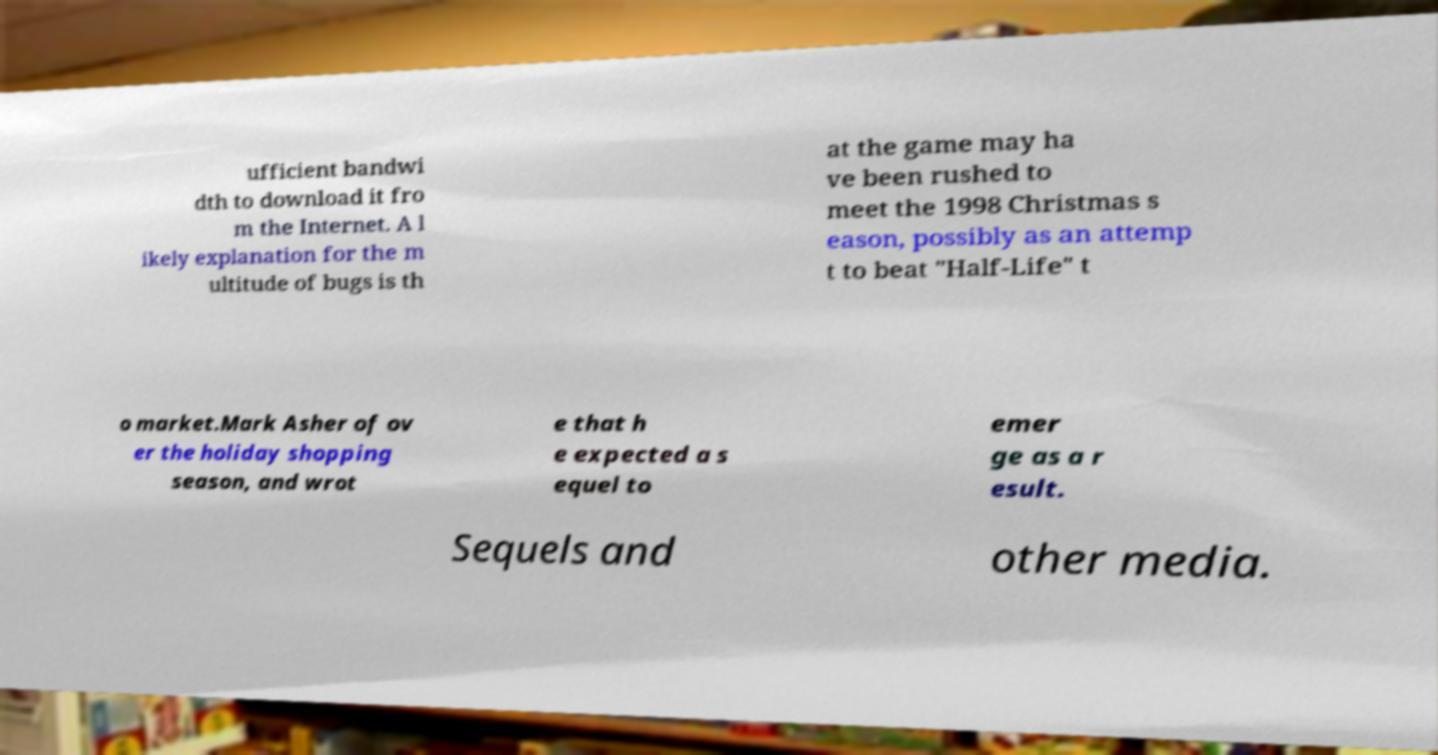I need the written content from this picture converted into text. Can you do that? ufficient bandwi dth to download it fro m the Internet. A l ikely explanation for the m ultitude of bugs is th at the game may ha ve been rushed to meet the 1998 Christmas s eason, possibly as an attemp t to beat "Half-Life" t o market.Mark Asher of ov er the holiday shopping season, and wrot e that h e expected a s equel to emer ge as a r esult. Sequels and other media. 